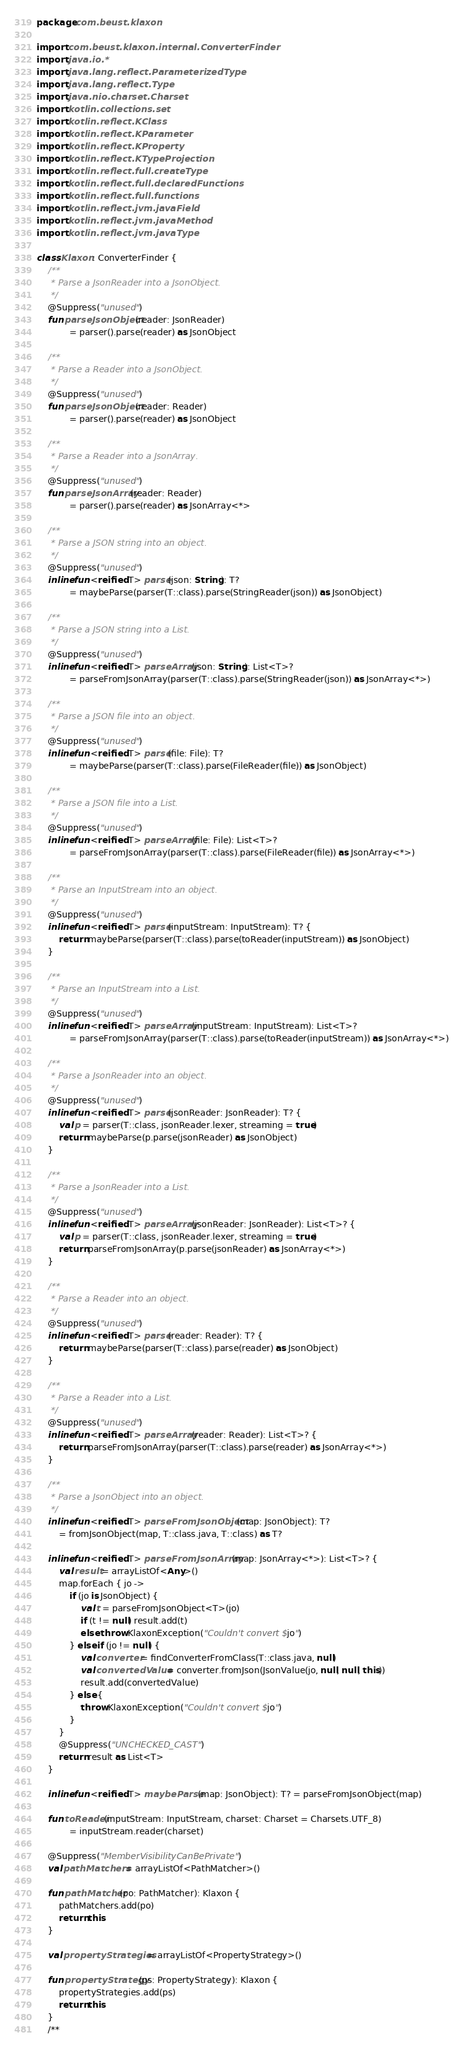<code> <loc_0><loc_0><loc_500><loc_500><_Kotlin_>package com.beust.klaxon

import com.beust.klaxon.internal.ConverterFinder
import java.io.*
import java.lang.reflect.ParameterizedType
import java.lang.reflect.Type
import java.nio.charset.Charset
import kotlin.collections.set
import kotlin.reflect.KClass
import kotlin.reflect.KParameter
import kotlin.reflect.KProperty
import kotlin.reflect.KTypeProjection
import kotlin.reflect.full.createType
import kotlin.reflect.full.declaredFunctions
import kotlin.reflect.full.functions
import kotlin.reflect.jvm.javaField
import kotlin.reflect.jvm.javaMethod
import kotlin.reflect.jvm.javaType

class Klaxon : ConverterFinder {
    /**
     * Parse a JsonReader into a JsonObject.
     */
    @Suppress("unused")
    fun parseJsonObject(reader: JsonReader)
            = parser().parse(reader) as JsonObject

    /**
     * Parse a Reader into a JsonObject.
     */
    @Suppress("unused")
    fun parseJsonObject(reader: Reader)
            = parser().parse(reader) as JsonObject

    /**
     * Parse a Reader into a JsonArray.
     */
    @Suppress("unused")
    fun parseJsonArray(reader: Reader)
            = parser().parse(reader) as JsonArray<*>

    /**
     * Parse a JSON string into an object.
     */
    @Suppress("unused")
    inline fun <reified T> parse(json: String): T?
            = maybeParse(parser(T::class).parse(StringReader(json)) as JsonObject)

    /**
     * Parse a JSON string into a List.
     */
    @Suppress("unused")
    inline fun <reified T> parseArray(json: String): List<T>?
            = parseFromJsonArray(parser(T::class).parse(StringReader(json)) as JsonArray<*>)

    /**
     * Parse a JSON file into an object.
     */
    @Suppress("unused")
    inline fun <reified T> parse(file: File): T?
            = maybeParse(parser(T::class).parse(FileReader(file)) as JsonObject)

    /**
     * Parse a JSON file into a List.
     */
    @Suppress("unused")
    inline fun <reified T> parseArray(file: File): List<T>?
            = parseFromJsonArray(parser(T::class).parse(FileReader(file)) as JsonArray<*>)

    /**
     * Parse an InputStream into an object.
     */
    @Suppress("unused")
    inline fun <reified T> parse(inputStream: InputStream): T? {
        return maybeParse(parser(T::class).parse(toReader(inputStream)) as JsonObject)
    }

    /**
     * Parse an InputStream into a List.
     */
    @Suppress("unused")
    inline fun <reified T> parseArray(inputStream: InputStream): List<T>?
            = parseFromJsonArray(parser(T::class).parse(toReader(inputStream)) as JsonArray<*>)

    /**
     * Parse a JsonReader into an object.
     */
    @Suppress("unused")
    inline fun <reified T> parse(jsonReader: JsonReader): T? {
        val p = parser(T::class, jsonReader.lexer, streaming = true)
        return maybeParse(p.parse(jsonReader) as JsonObject)
    }

    /**
     * Parse a JsonReader into a List.
     */
    @Suppress("unused")
    inline fun <reified T> parseArray(jsonReader: JsonReader): List<T>? {
        val p = parser(T::class, jsonReader.lexer, streaming = true)
        return parseFromJsonArray(p.parse(jsonReader) as JsonArray<*>)
    }

    /**
     * Parse a Reader into an object.
     */
    @Suppress("unused")
    inline fun <reified T> parse(reader: Reader): T? {
        return maybeParse(parser(T::class).parse(reader) as JsonObject)
    }

    /**
     * Parse a Reader into a List.
     */
    @Suppress("unused")
    inline fun <reified T> parseArray(reader: Reader): List<T>? {
        return parseFromJsonArray(parser(T::class).parse(reader) as JsonArray<*>)
    }

    /**
     * Parse a JsonObject into an object.
     */
    inline fun <reified T> parseFromJsonObject(map: JsonObject): T?
        = fromJsonObject(map, T::class.java, T::class) as T?

    inline fun <reified T> parseFromJsonArray(map: JsonArray<*>): List<T>? {
        val result = arrayListOf<Any>()
        map.forEach { jo ->
            if (jo is JsonObject) {
                val t = parseFromJsonObject<T>(jo)
                if (t != null) result.add(t)
                else throw KlaxonException("Couldn't convert $jo")
            } else if (jo != null) {
                val converter = findConverterFromClass(T::class.java, null)
                val convertedValue = converter.fromJson(JsonValue(jo, null, null, this))
                result.add(convertedValue)
            } else {
                throw KlaxonException("Couldn't convert $jo")
            }
        }
        @Suppress("UNCHECKED_CAST")
        return result as List<T>
    }

    inline fun <reified T> maybeParse(map: JsonObject): T? = parseFromJsonObject(map)

    fun toReader(inputStream: InputStream, charset: Charset = Charsets.UTF_8)
            = inputStream.reader(charset)

    @Suppress("MemberVisibilityCanBePrivate")
    val pathMatchers = arrayListOf<PathMatcher>()

    fun pathMatcher(po: PathMatcher): Klaxon {
        pathMatchers.add(po)
        return this
    }

    val propertyStrategies = arrayListOf<PropertyStrategy>()

    fun propertyStrategy(ps: PropertyStrategy): Klaxon {
        propertyStrategies.add(ps)
        return this
    }
    /**</code> 